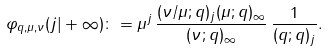Convert formula to latex. <formula><loc_0><loc_0><loc_500><loc_500>\varphi _ { q , \mu , \nu } ( j | + \infty ) \colon = \mu ^ { j } \, \frac { ( \nu / \mu ; q ) _ { j } ( \mu ; q ) _ { \infty } } { ( \nu ; q ) _ { \infty } } \, \frac { 1 } { ( q ; q ) _ { j } } .</formula> 